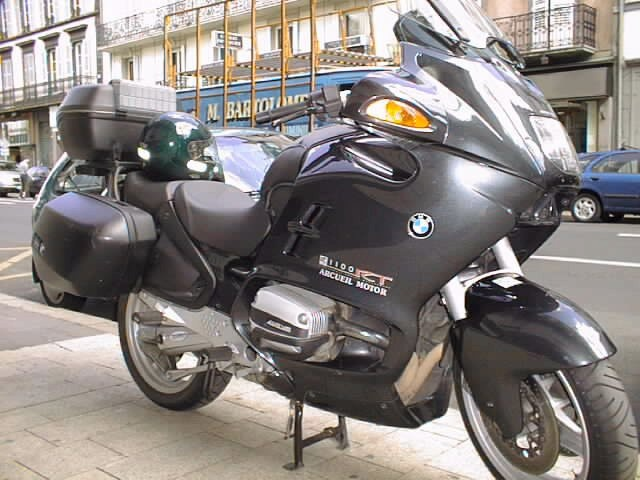Describe the objects in this image and their specific colors. I can see motorcycle in purple, gray, black, darkgray, and lightgray tones, car in purple, lavender, darkgray, gray, and black tones, car in purple, black, gray, and darkgray tones, and car in purple, white, gray, darkgray, and black tones in this image. 